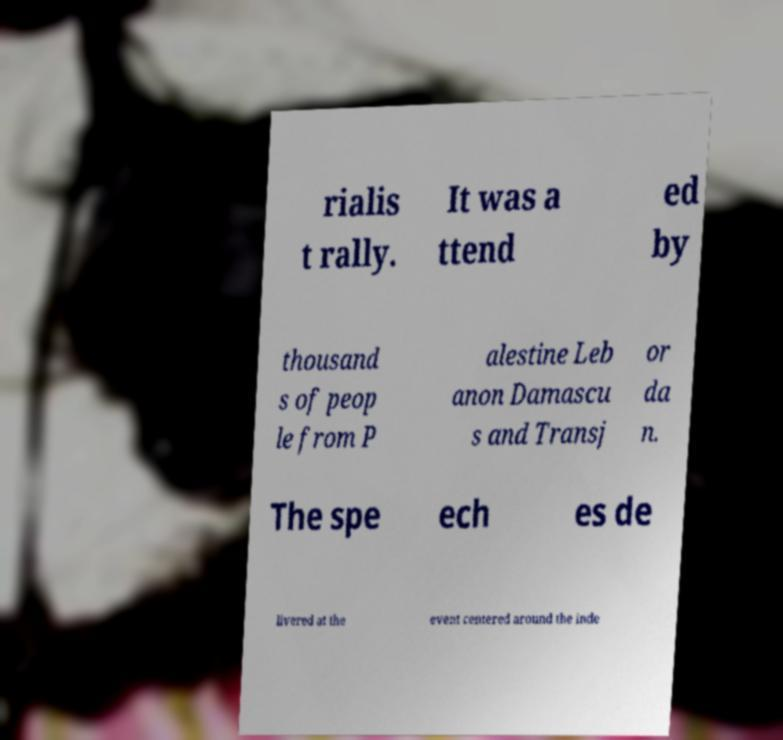Could you extract and type out the text from this image? rialis t rally. It was a ttend ed by thousand s of peop le from P alestine Leb anon Damascu s and Transj or da n. The spe ech es de livered at the event centered around the inde 